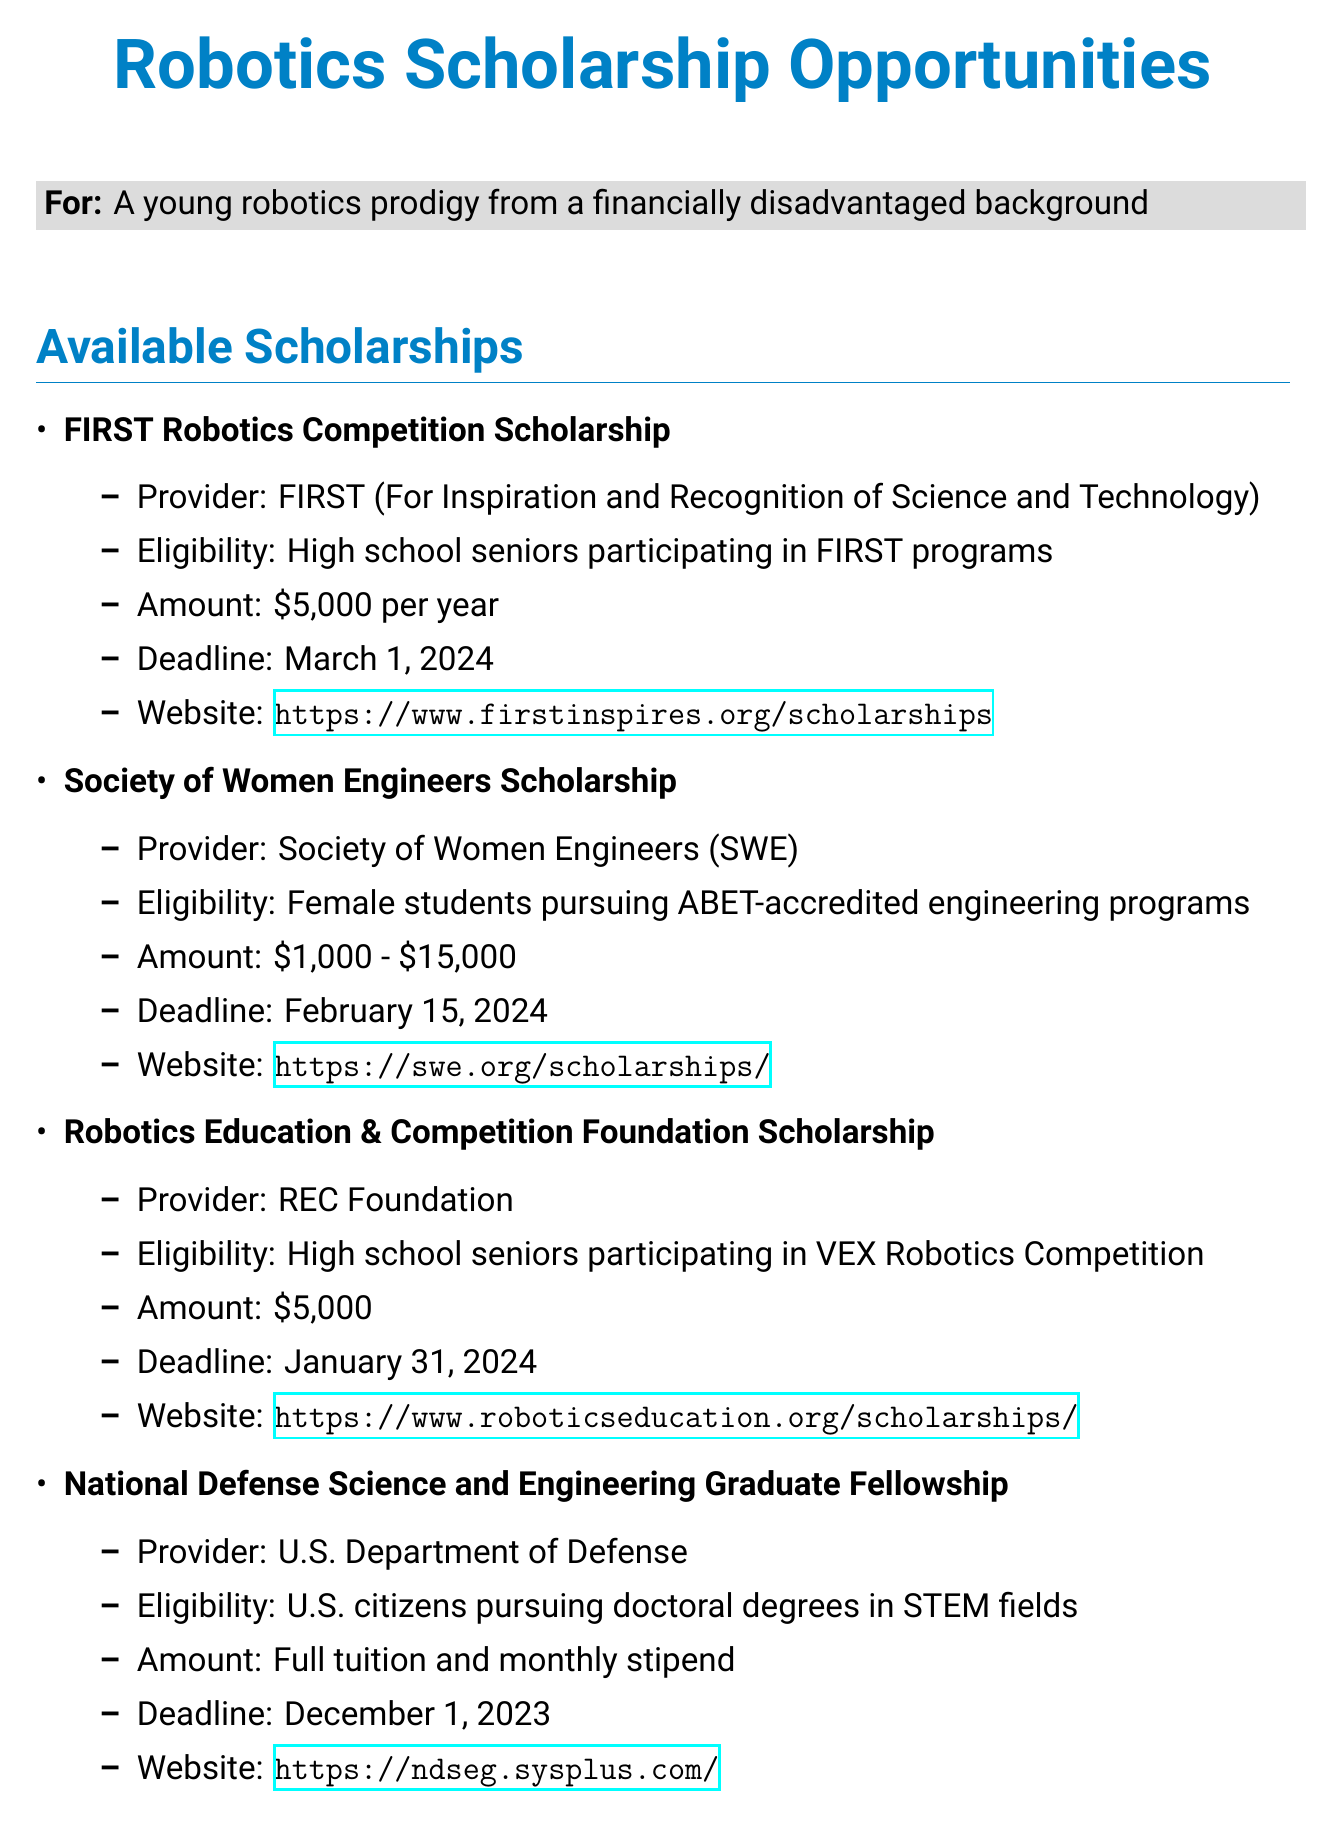What is the amount of the FIRST Robotics Competition Scholarship? The amount is listed in the document as $5,000 per year.
Answer: $5,000 per year What is the website link for the Society of Women Engineers Scholarship? The website link is provided in the document for this scholarship.
Answer: https://swe.org/scholarships/ What is the application deadline for the Robotics Education & Competition Foundation Scholarship? The deadline is specified in the document as January 31, 2024.
Answer: January 31, 2024 Who is eligible for the National Defense Science and Engineering Graduate Fellowship? The eligibility criteria are outlined in the document, specifying U.S. citizens pursuing doctoral degrees in STEM fields.
Answer: U.S. citizens pursuing doctoral degrees in STEM fields Which scholarship offers a range of amounts from $1,000 to $15,000? The document mentions this amount range for the Society of Women Engineers Scholarship.
Answer: Society of Women Engineers Scholarship What is a financial aid tip mentioned in the document? The document lists several tips, such as maintaining a high GPA to increase eligibility for merit-based scholarships.
Answer: Maintain a high GPA to increase eligibility for merit-based scholarships What organization provides the FIRST Robotics Competition Scholarship? The document specifies that this scholarship is provided by FIRST (For Inspiration and Recognition of Science and Technology).
Answer: FIRST (For Inspiration and Recognition of Science and Technology) When is National Robotics Week? The specific date is not mentioned, but it is referred to as an annual event in the document.
Answer: Annual event 